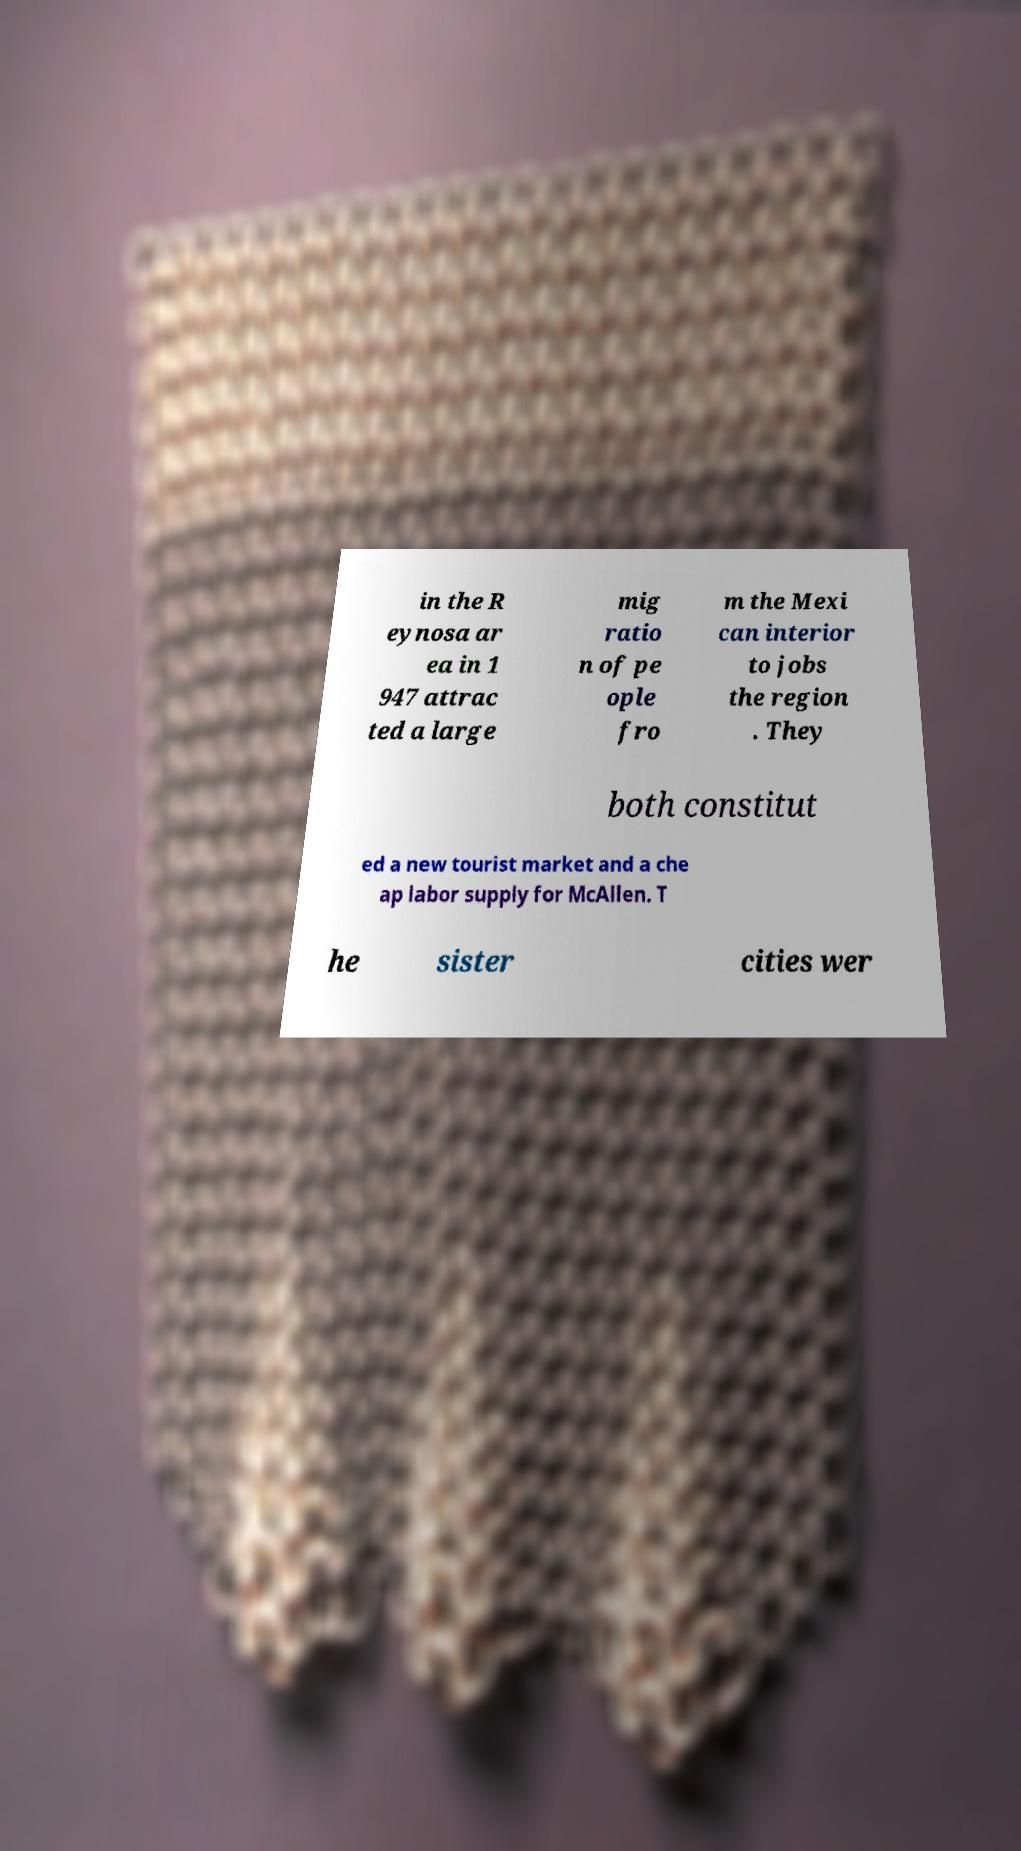Can you accurately transcribe the text from the provided image for me? in the R eynosa ar ea in 1 947 attrac ted a large mig ratio n of pe ople fro m the Mexi can interior to jobs the region . They both constitut ed a new tourist market and a che ap labor supply for McAllen. T he sister cities wer 